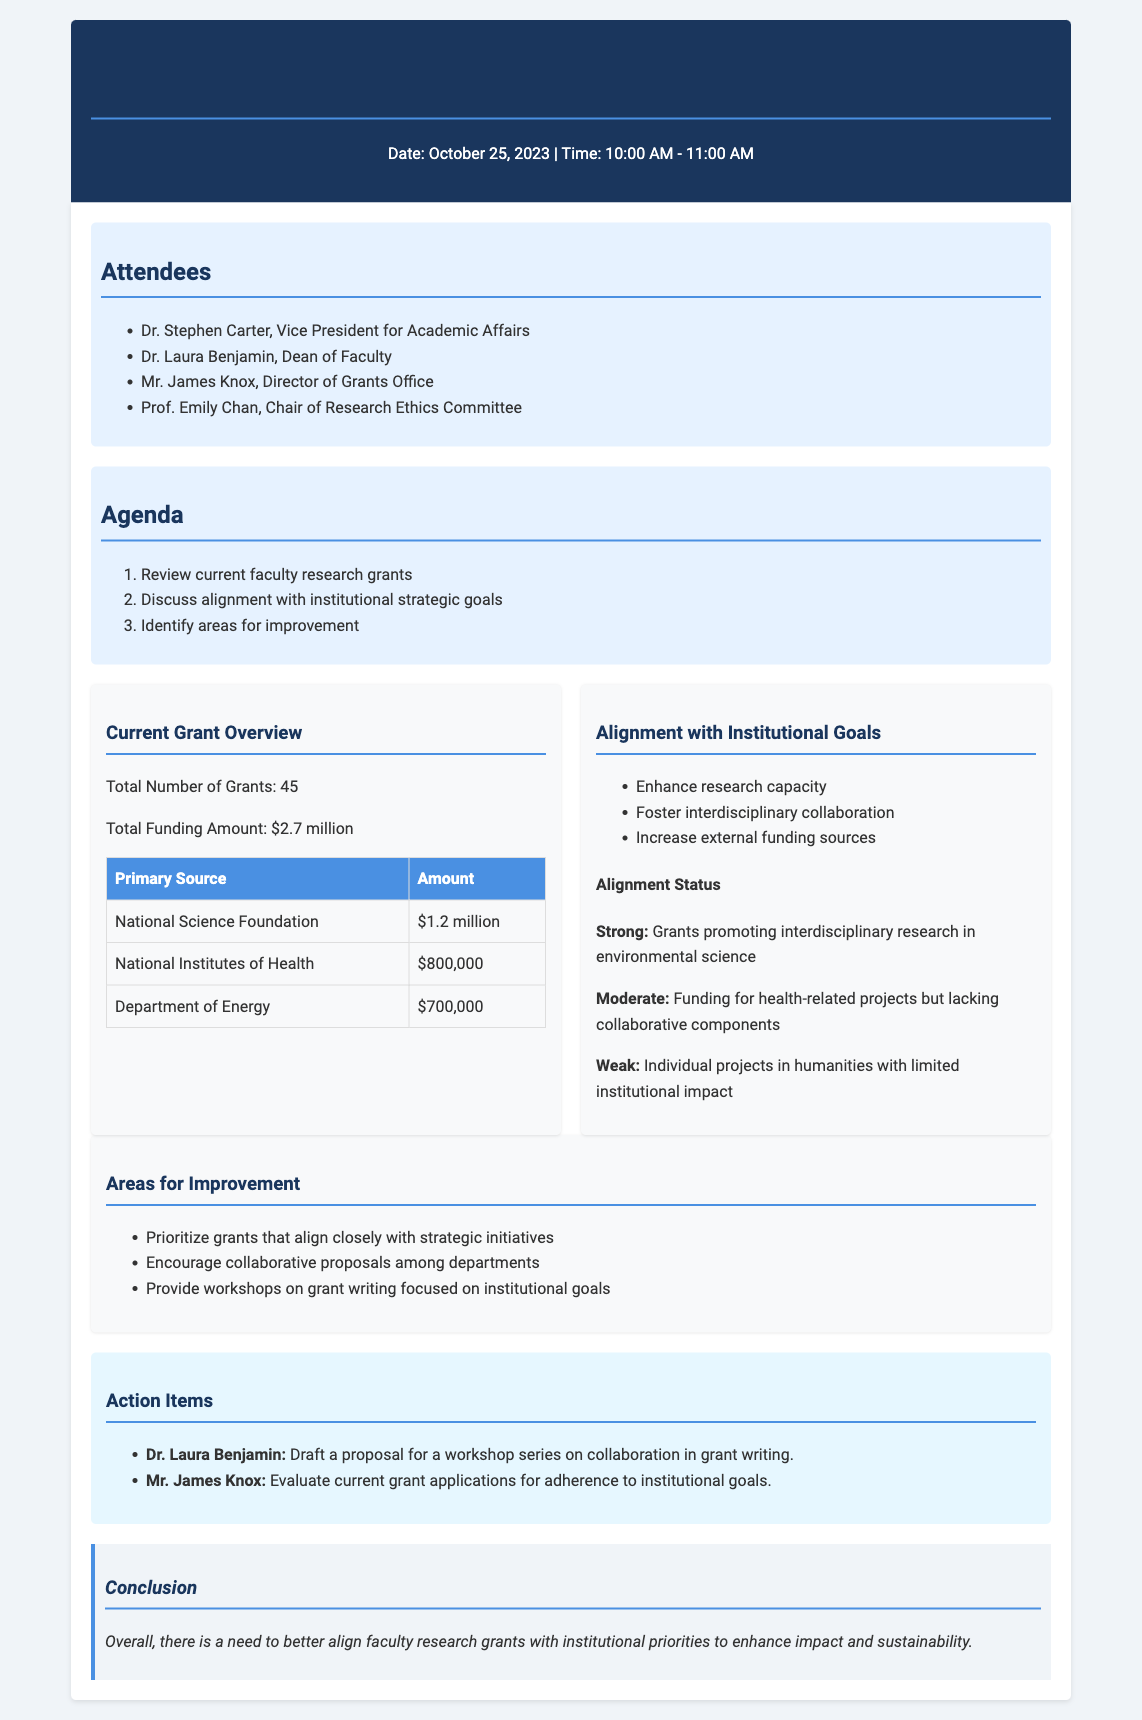What is the date of the meeting? The date of the meeting is specified in the header of the document.
Answer: October 25, 2023 How many attendees were present at the meeting? The number of attendees is listed under the attendees section.
Answer: 4 What was the total funding amount for the grants? The total funding amount is provided in the current grant overview section.
Answer: $2.7 million Which organization provided the highest amount of funding? The primary funding sources and their amounts are detailed in a table in the document.
Answer: National Science Foundation What was the alignment status of grants promoting interdisciplinary research? The alignment status is described in the alignment section, indicating the strength of grants.
Answer: Strong What specific area for improvement was noted in the meeting? Areas for improvement are listed and indicate the focus for future actions.
Answer: Prioritize grants that align closely with strategic initiatives What action item was assigned to Dr. Laura Benjamin? The action items section lists responsibilities for attendees.
Answer: Draft a proposal for a workshop series on collaboration in grant writing What type of grants received a moderate alignment status? The alignment section specifies which grants fall into each category of alignment.
Answer: Funding for health-related projects but lacking collaborative components What was the main conclusion of the meeting? The conclusion summarizes the overall outcome and focus of the meeting's discussions.
Answer: Overall, there is a need to better align faculty research grants with institutional priorities to enhance impact and sustainability 